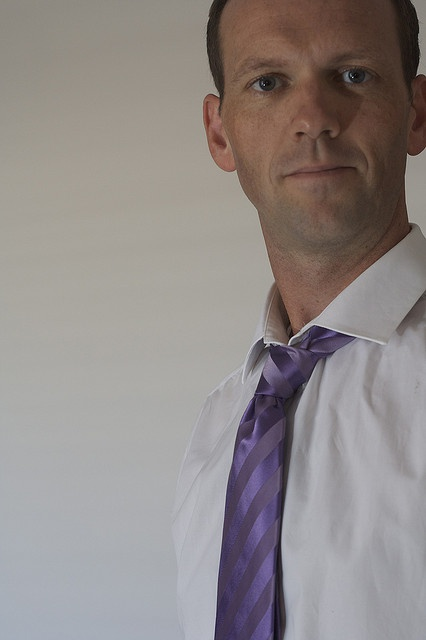Describe the objects in this image and their specific colors. I can see people in gray, darkgray, and maroon tones and tie in gray, purple, and black tones in this image. 